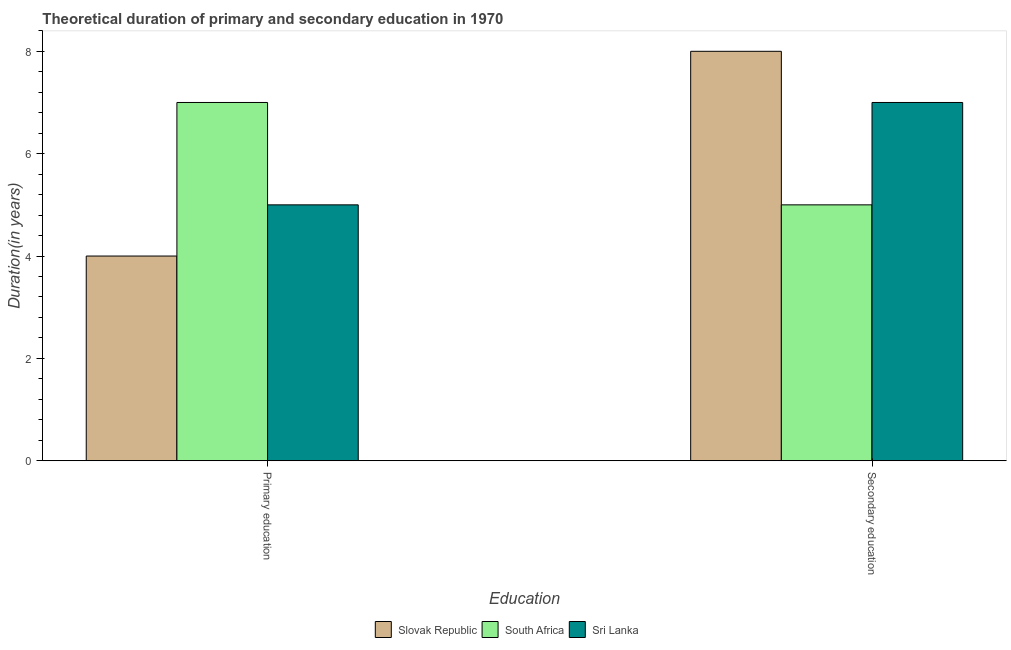How many different coloured bars are there?
Provide a short and direct response. 3. How many groups of bars are there?
Offer a very short reply. 2. What is the label of the 2nd group of bars from the left?
Keep it short and to the point. Secondary education. What is the duration of primary education in Slovak Republic?
Your answer should be very brief. 4. Across all countries, what is the maximum duration of secondary education?
Your answer should be very brief. 8. Across all countries, what is the minimum duration of secondary education?
Provide a succinct answer. 5. In which country was the duration of secondary education maximum?
Keep it short and to the point. Slovak Republic. In which country was the duration of primary education minimum?
Offer a terse response. Slovak Republic. What is the total duration of primary education in the graph?
Ensure brevity in your answer.  16. What is the difference between the duration of primary education in Sri Lanka and that in South Africa?
Provide a short and direct response. -2. What is the difference between the duration of secondary education in Slovak Republic and the duration of primary education in South Africa?
Your response must be concise. 1. What is the average duration of secondary education per country?
Keep it short and to the point. 6.67. What is the difference between the duration of primary education and duration of secondary education in Sri Lanka?
Your answer should be compact. -2. What is the ratio of the duration of secondary education in Sri Lanka to that in Slovak Republic?
Keep it short and to the point. 0.88. What does the 2nd bar from the left in Primary education represents?
Give a very brief answer. South Africa. What does the 1st bar from the right in Secondary education represents?
Provide a short and direct response. Sri Lanka. How many countries are there in the graph?
Provide a succinct answer. 3. What is the difference between two consecutive major ticks on the Y-axis?
Your answer should be very brief. 2. Does the graph contain any zero values?
Keep it short and to the point. No. Where does the legend appear in the graph?
Your response must be concise. Bottom center. How many legend labels are there?
Your response must be concise. 3. How are the legend labels stacked?
Offer a very short reply. Horizontal. What is the title of the graph?
Provide a succinct answer. Theoretical duration of primary and secondary education in 1970. Does "Belarus" appear as one of the legend labels in the graph?
Keep it short and to the point. No. What is the label or title of the X-axis?
Offer a very short reply. Education. What is the label or title of the Y-axis?
Provide a succinct answer. Duration(in years). What is the Duration(in years) in Slovak Republic in Primary education?
Provide a succinct answer. 4. What is the Duration(in years) of South Africa in Primary education?
Ensure brevity in your answer.  7. What is the Duration(in years) in Sri Lanka in Primary education?
Provide a succinct answer. 5. What is the Duration(in years) of Slovak Republic in Secondary education?
Provide a succinct answer. 8. What is the Duration(in years) of South Africa in Secondary education?
Your answer should be compact. 5. Across all Education, what is the maximum Duration(in years) of South Africa?
Make the answer very short. 7. Across all Education, what is the maximum Duration(in years) of Sri Lanka?
Provide a short and direct response. 7. Across all Education, what is the minimum Duration(in years) of Slovak Republic?
Make the answer very short. 4. Across all Education, what is the minimum Duration(in years) of South Africa?
Your response must be concise. 5. What is the total Duration(in years) of South Africa in the graph?
Your response must be concise. 12. What is the difference between the Duration(in years) of Slovak Republic in Primary education and that in Secondary education?
Make the answer very short. -4. What is the difference between the Duration(in years) in Sri Lanka in Primary education and that in Secondary education?
Your answer should be very brief. -2. What is the average Duration(in years) of South Africa per Education?
Provide a short and direct response. 6. What is the average Duration(in years) in Sri Lanka per Education?
Your response must be concise. 6. What is the difference between the Duration(in years) in South Africa and Duration(in years) in Sri Lanka in Primary education?
Your answer should be very brief. 2. What is the ratio of the Duration(in years) in Slovak Republic in Primary education to that in Secondary education?
Your answer should be compact. 0.5. What is the ratio of the Duration(in years) of South Africa in Primary education to that in Secondary education?
Offer a very short reply. 1.4. What is the difference between the highest and the second highest Duration(in years) of Slovak Republic?
Your response must be concise. 4. What is the difference between the highest and the second highest Duration(in years) in South Africa?
Make the answer very short. 2. What is the difference between the highest and the second highest Duration(in years) in Sri Lanka?
Provide a short and direct response. 2. What is the difference between the highest and the lowest Duration(in years) in Slovak Republic?
Your answer should be compact. 4. 